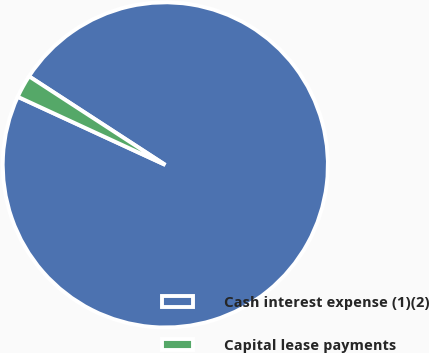Convert chart. <chart><loc_0><loc_0><loc_500><loc_500><pie_chart><fcel>Cash interest expense (1)(2)<fcel>Capital lease payments<nl><fcel>97.71%<fcel>2.29%<nl></chart> 